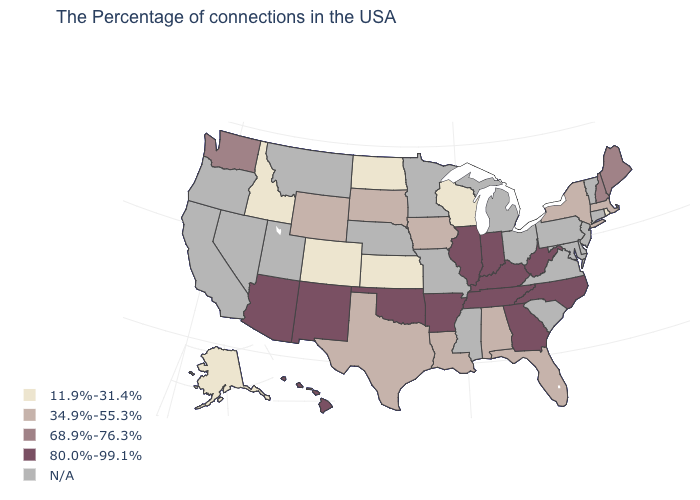What is the highest value in the MidWest ?
Give a very brief answer. 80.0%-99.1%. Among the states that border Massachusetts , does New Hampshire have the highest value?
Answer briefly. Yes. What is the value of Wisconsin?
Answer briefly. 11.9%-31.4%. How many symbols are there in the legend?
Short answer required. 5. Name the states that have a value in the range 11.9%-31.4%?
Write a very short answer. Rhode Island, Wisconsin, Kansas, North Dakota, Colorado, Idaho, Alaska. What is the lowest value in states that border Maryland?
Give a very brief answer. 80.0%-99.1%. Name the states that have a value in the range 68.9%-76.3%?
Short answer required. Maine, New Hampshire, Washington. What is the value of Maine?
Give a very brief answer. 68.9%-76.3%. Among the states that border Maryland , which have the lowest value?
Write a very short answer. West Virginia. Name the states that have a value in the range 80.0%-99.1%?
Concise answer only. North Carolina, West Virginia, Georgia, Kentucky, Indiana, Tennessee, Illinois, Arkansas, Oklahoma, New Mexico, Arizona, Hawaii. Among the states that border Vermont , which have the lowest value?
Write a very short answer. Massachusetts, New York. How many symbols are there in the legend?
Write a very short answer. 5. What is the value of Indiana?
Give a very brief answer. 80.0%-99.1%. 